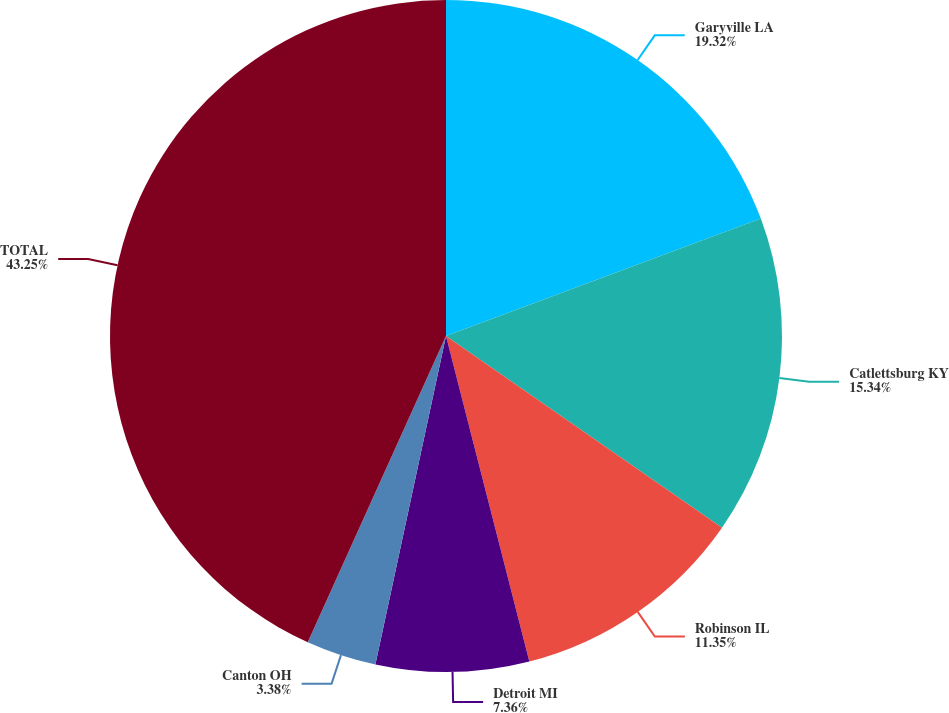Convert chart. <chart><loc_0><loc_0><loc_500><loc_500><pie_chart><fcel>Garyville LA<fcel>Catlettsburg KY<fcel>Robinson IL<fcel>Detroit MI<fcel>Canton OH<fcel>TOTAL<nl><fcel>19.32%<fcel>15.34%<fcel>11.35%<fcel>7.36%<fcel>3.38%<fcel>43.25%<nl></chart> 